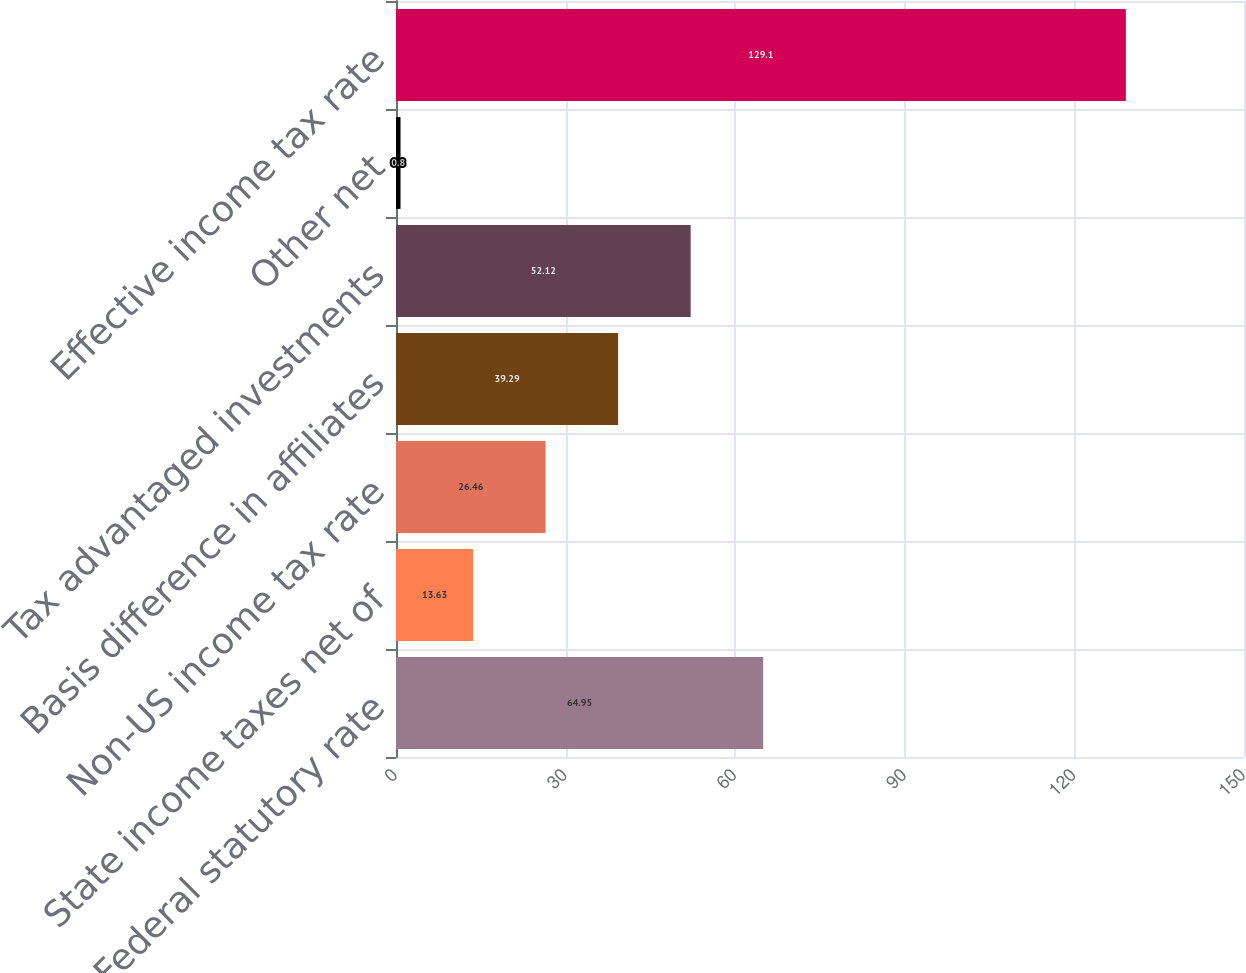Convert chart. <chart><loc_0><loc_0><loc_500><loc_500><bar_chart><fcel>Federal statutory rate<fcel>State income taxes net of<fcel>Non-US income tax rate<fcel>Basis difference in affiliates<fcel>Tax advantaged investments<fcel>Other net<fcel>Effective income tax rate<nl><fcel>64.95<fcel>13.63<fcel>26.46<fcel>39.29<fcel>52.12<fcel>0.8<fcel>129.1<nl></chart> 